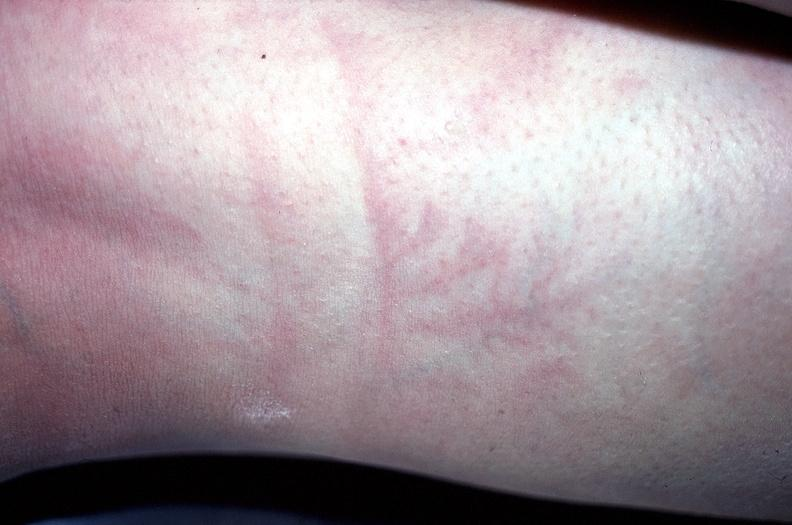does this image show arm, lightning strike - ferning?
Answer the question using a single word or phrase. Yes 